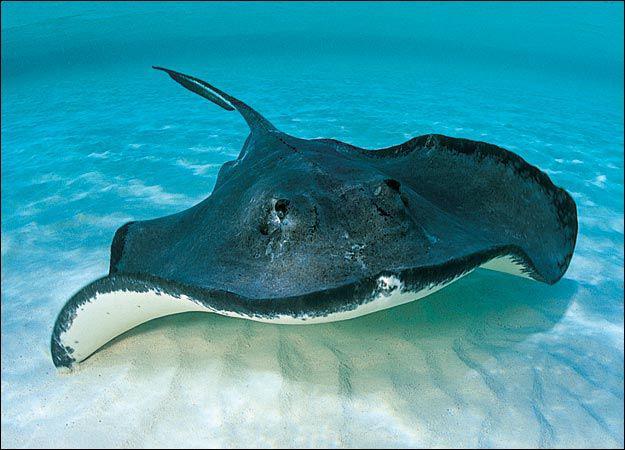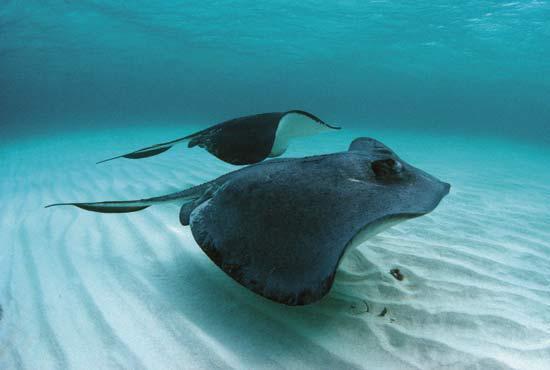The first image is the image on the left, the second image is the image on the right. Given the left and right images, does the statement "Two stingray are present in the right image." hold true? Answer yes or no. Yes. 